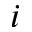<formula> <loc_0><loc_0><loc_500><loc_500>i</formula> 